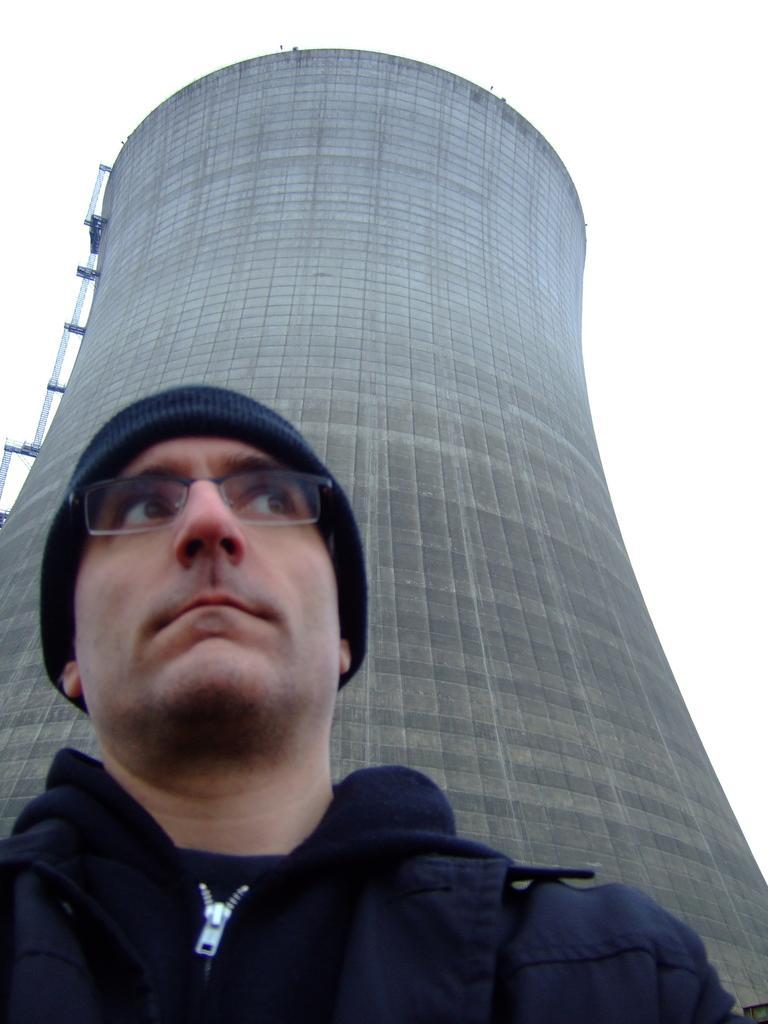Please provide a concise description of this image. In this picture we can see a man wore a cap, spectacle and in the background we can see a building. 